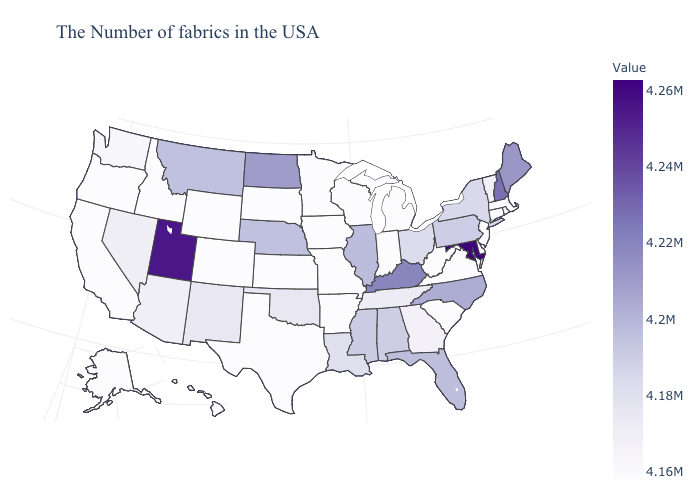Among the states that border Ohio , does Indiana have the lowest value?
Be succinct. Yes. Is the legend a continuous bar?
Write a very short answer. Yes. Does Montana have the highest value in the USA?
Write a very short answer. No. Which states have the lowest value in the Northeast?
Concise answer only. Massachusetts, Rhode Island, Connecticut, New Jersey. Does Oregon have the lowest value in the USA?
Be succinct. Yes. Does Arizona have a higher value than South Dakota?
Quick response, please. Yes. Among the states that border Mississippi , does Louisiana have the highest value?
Write a very short answer. No. Does Oregon have a higher value than New Hampshire?
Short answer required. No. 